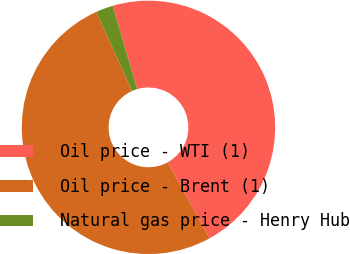Convert chart. <chart><loc_0><loc_0><loc_500><loc_500><pie_chart><fcel>Oil price - WTI (1)<fcel>Oil price - Brent (1)<fcel>Natural gas price - Henry Hub<nl><fcel>46.55%<fcel>51.27%<fcel>2.19%<nl></chart> 